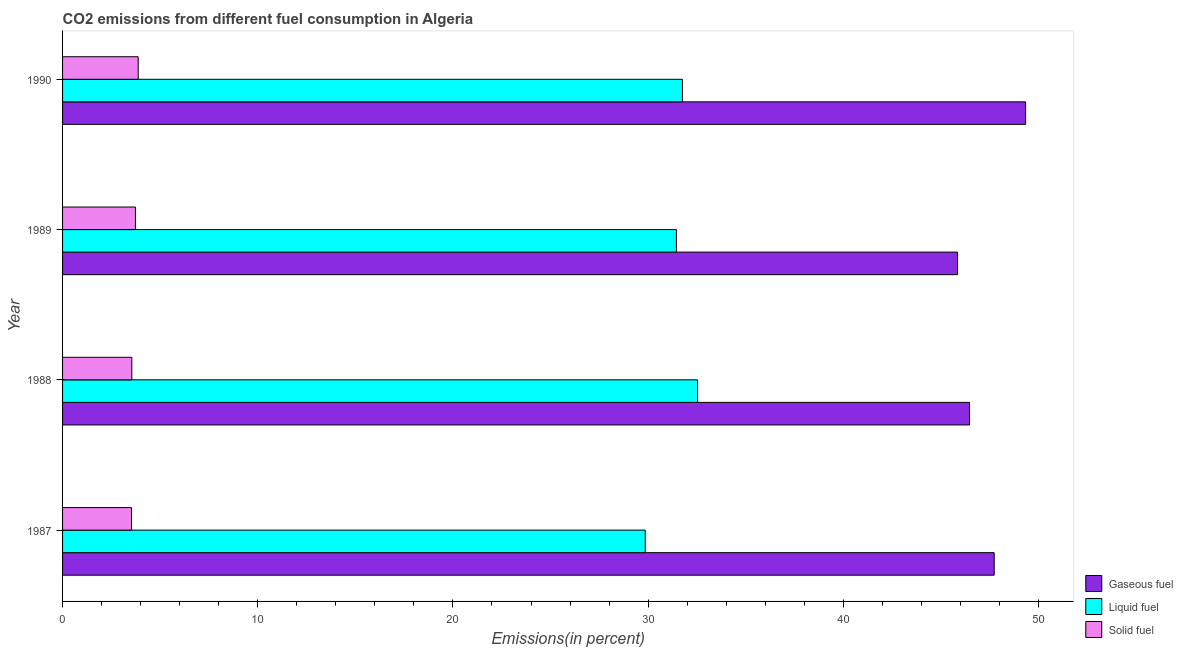How many different coloured bars are there?
Provide a short and direct response. 3. How many groups of bars are there?
Provide a succinct answer. 4. Are the number of bars per tick equal to the number of legend labels?
Make the answer very short. Yes. Are the number of bars on each tick of the Y-axis equal?
Ensure brevity in your answer.  Yes. How many bars are there on the 1st tick from the bottom?
Your response must be concise. 3. What is the percentage of gaseous fuel emission in 1988?
Your response must be concise. 46.46. Across all years, what is the maximum percentage of liquid fuel emission?
Keep it short and to the point. 32.53. Across all years, what is the minimum percentage of solid fuel emission?
Offer a very short reply. 3.53. In which year was the percentage of liquid fuel emission maximum?
Provide a short and direct response. 1988. In which year was the percentage of solid fuel emission minimum?
Keep it short and to the point. 1987. What is the total percentage of gaseous fuel emission in the graph?
Provide a succinct answer. 189.38. What is the difference between the percentage of gaseous fuel emission in 1987 and that in 1988?
Your answer should be compact. 1.26. What is the difference between the percentage of solid fuel emission in 1990 and the percentage of liquid fuel emission in 1988?
Your response must be concise. -28.65. What is the average percentage of liquid fuel emission per year?
Make the answer very short. 31.4. In the year 1990, what is the difference between the percentage of solid fuel emission and percentage of gaseous fuel emission?
Offer a very short reply. -45.46. In how many years, is the percentage of solid fuel emission greater than 26 %?
Make the answer very short. 0. What is the ratio of the percentage of liquid fuel emission in 1987 to that in 1988?
Provide a succinct answer. 0.92. Is the percentage of gaseous fuel emission in 1987 less than that in 1989?
Make the answer very short. No. What is the difference between the highest and the second highest percentage of liquid fuel emission?
Your answer should be very brief. 0.77. What is the difference between the highest and the lowest percentage of solid fuel emission?
Offer a very short reply. 0.34. In how many years, is the percentage of liquid fuel emission greater than the average percentage of liquid fuel emission taken over all years?
Give a very brief answer. 3. Is the sum of the percentage of solid fuel emission in 1988 and 1990 greater than the maximum percentage of gaseous fuel emission across all years?
Provide a short and direct response. No. What does the 2nd bar from the top in 1989 represents?
Make the answer very short. Liquid fuel. What does the 2nd bar from the bottom in 1988 represents?
Your answer should be compact. Liquid fuel. Is it the case that in every year, the sum of the percentage of gaseous fuel emission and percentage of liquid fuel emission is greater than the percentage of solid fuel emission?
Keep it short and to the point. Yes. Are all the bars in the graph horizontal?
Make the answer very short. Yes. Does the graph contain any zero values?
Your answer should be compact. No. How many legend labels are there?
Offer a very short reply. 3. How are the legend labels stacked?
Your answer should be very brief. Vertical. What is the title of the graph?
Provide a succinct answer. CO2 emissions from different fuel consumption in Algeria. Does "Ages 65 and above" appear as one of the legend labels in the graph?
Provide a short and direct response. No. What is the label or title of the X-axis?
Your response must be concise. Emissions(in percent). What is the label or title of the Y-axis?
Make the answer very short. Year. What is the Emissions(in percent) of Gaseous fuel in 1987?
Give a very brief answer. 47.73. What is the Emissions(in percent) of Liquid fuel in 1987?
Keep it short and to the point. 29.85. What is the Emissions(in percent) of Solid fuel in 1987?
Make the answer very short. 3.53. What is the Emissions(in percent) of Gaseous fuel in 1988?
Keep it short and to the point. 46.46. What is the Emissions(in percent) of Liquid fuel in 1988?
Your answer should be compact. 32.53. What is the Emissions(in percent) in Solid fuel in 1988?
Your response must be concise. 3.55. What is the Emissions(in percent) in Gaseous fuel in 1989?
Provide a short and direct response. 45.85. What is the Emissions(in percent) in Liquid fuel in 1989?
Ensure brevity in your answer.  31.45. What is the Emissions(in percent) in Solid fuel in 1989?
Your answer should be compact. 3.73. What is the Emissions(in percent) in Gaseous fuel in 1990?
Your answer should be very brief. 49.34. What is the Emissions(in percent) of Liquid fuel in 1990?
Offer a very short reply. 31.76. What is the Emissions(in percent) of Solid fuel in 1990?
Keep it short and to the point. 3.87. Across all years, what is the maximum Emissions(in percent) in Gaseous fuel?
Provide a succinct answer. 49.34. Across all years, what is the maximum Emissions(in percent) in Liquid fuel?
Offer a very short reply. 32.53. Across all years, what is the maximum Emissions(in percent) in Solid fuel?
Make the answer very short. 3.87. Across all years, what is the minimum Emissions(in percent) of Gaseous fuel?
Your answer should be very brief. 45.85. Across all years, what is the minimum Emissions(in percent) of Liquid fuel?
Provide a short and direct response. 29.85. Across all years, what is the minimum Emissions(in percent) of Solid fuel?
Make the answer very short. 3.53. What is the total Emissions(in percent) in Gaseous fuel in the graph?
Offer a very short reply. 189.38. What is the total Emissions(in percent) in Liquid fuel in the graph?
Give a very brief answer. 125.59. What is the total Emissions(in percent) in Solid fuel in the graph?
Keep it short and to the point. 14.69. What is the difference between the Emissions(in percent) in Gaseous fuel in 1987 and that in 1988?
Your response must be concise. 1.26. What is the difference between the Emissions(in percent) of Liquid fuel in 1987 and that in 1988?
Your answer should be very brief. -2.68. What is the difference between the Emissions(in percent) in Solid fuel in 1987 and that in 1988?
Give a very brief answer. -0.02. What is the difference between the Emissions(in percent) of Gaseous fuel in 1987 and that in 1989?
Your answer should be very brief. 1.88. What is the difference between the Emissions(in percent) of Liquid fuel in 1987 and that in 1989?
Provide a short and direct response. -1.6. What is the difference between the Emissions(in percent) of Solid fuel in 1987 and that in 1989?
Offer a terse response. -0.2. What is the difference between the Emissions(in percent) of Gaseous fuel in 1987 and that in 1990?
Offer a terse response. -1.61. What is the difference between the Emissions(in percent) of Liquid fuel in 1987 and that in 1990?
Your answer should be compact. -1.9. What is the difference between the Emissions(in percent) of Solid fuel in 1987 and that in 1990?
Your answer should be very brief. -0.34. What is the difference between the Emissions(in percent) in Gaseous fuel in 1988 and that in 1989?
Keep it short and to the point. 0.61. What is the difference between the Emissions(in percent) in Liquid fuel in 1988 and that in 1989?
Give a very brief answer. 1.08. What is the difference between the Emissions(in percent) in Solid fuel in 1988 and that in 1989?
Provide a succinct answer. -0.19. What is the difference between the Emissions(in percent) in Gaseous fuel in 1988 and that in 1990?
Give a very brief answer. -2.87. What is the difference between the Emissions(in percent) of Liquid fuel in 1988 and that in 1990?
Make the answer very short. 0.77. What is the difference between the Emissions(in percent) of Solid fuel in 1988 and that in 1990?
Ensure brevity in your answer.  -0.33. What is the difference between the Emissions(in percent) in Gaseous fuel in 1989 and that in 1990?
Make the answer very short. -3.49. What is the difference between the Emissions(in percent) of Liquid fuel in 1989 and that in 1990?
Offer a very short reply. -0.31. What is the difference between the Emissions(in percent) in Solid fuel in 1989 and that in 1990?
Offer a terse response. -0.14. What is the difference between the Emissions(in percent) in Gaseous fuel in 1987 and the Emissions(in percent) in Liquid fuel in 1988?
Offer a very short reply. 15.2. What is the difference between the Emissions(in percent) of Gaseous fuel in 1987 and the Emissions(in percent) of Solid fuel in 1988?
Provide a succinct answer. 44.18. What is the difference between the Emissions(in percent) in Liquid fuel in 1987 and the Emissions(in percent) in Solid fuel in 1988?
Provide a short and direct response. 26.3. What is the difference between the Emissions(in percent) of Gaseous fuel in 1987 and the Emissions(in percent) of Liquid fuel in 1989?
Ensure brevity in your answer.  16.28. What is the difference between the Emissions(in percent) in Gaseous fuel in 1987 and the Emissions(in percent) in Solid fuel in 1989?
Ensure brevity in your answer.  44. What is the difference between the Emissions(in percent) in Liquid fuel in 1987 and the Emissions(in percent) in Solid fuel in 1989?
Provide a succinct answer. 26.12. What is the difference between the Emissions(in percent) of Gaseous fuel in 1987 and the Emissions(in percent) of Liquid fuel in 1990?
Your answer should be compact. 15.97. What is the difference between the Emissions(in percent) of Gaseous fuel in 1987 and the Emissions(in percent) of Solid fuel in 1990?
Keep it short and to the point. 43.85. What is the difference between the Emissions(in percent) in Liquid fuel in 1987 and the Emissions(in percent) in Solid fuel in 1990?
Ensure brevity in your answer.  25.98. What is the difference between the Emissions(in percent) of Gaseous fuel in 1988 and the Emissions(in percent) of Liquid fuel in 1989?
Ensure brevity in your answer.  15.02. What is the difference between the Emissions(in percent) in Gaseous fuel in 1988 and the Emissions(in percent) in Solid fuel in 1989?
Your answer should be very brief. 42.73. What is the difference between the Emissions(in percent) of Liquid fuel in 1988 and the Emissions(in percent) of Solid fuel in 1989?
Offer a terse response. 28.8. What is the difference between the Emissions(in percent) of Gaseous fuel in 1988 and the Emissions(in percent) of Liquid fuel in 1990?
Provide a short and direct response. 14.71. What is the difference between the Emissions(in percent) in Gaseous fuel in 1988 and the Emissions(in percent) in Solid fuel in 1990?
Your answer should be very brief. 42.59. What is the difference between the Emissions(in percent) in Liquid fuel in 1988 and the Emissions(in percent) in Solid fuel in 1990?
Your response must be concise. 28.65. What is the difference between the Emissions(in percent) in Gaseous fuel in 1989 and the Emissions(in percent) in Liquid fuel in 1990?
Your answer should be compact. 14.1. What is the difference between the Emissions(in percent) in Gaseous fuel in 1989 and the Emissions(in percent) in Solid fuel in 1990?
Your answer should be compact. 41.98. What is the difference between the Emissions(in percent) in Liquid fuel in 1989 and the Emissions(in percent) in Solid fuel in 1990?
Offer a very short reply. 27.57. What is the average Emissions(in percent) of Gaseous fuel per year?
Give a very brief answer. 47.35. What is the average Emissions(in percent) of Liquid fuel per year?
Make the answer very short. 31.4. What is the average Emissions(in percent) in Solid fuel per year?
Offer a terse response. 3.67. In the year 1987, what is the difference between the Emissions(in percent) in Gaseous fuel and Emissions(in percent) in Liquid fuel?
Your response must be concise. 17.88. In the year 1987, what is the difference between the Emissions(in percent) in Gaseous fuel and Emissions(in percent) in Solid fuel?
Keep it short and to the point. 44.2. In the year 1987, what is the difference between the Emissions(in percent) of Liquid fuel and Emissions(in percent) of Solid fuel?
Your answer should be very brief. 26.32. In the year 1988, what is the difference between the Emissions(in percent) of Gaseous fuel and Emissions(in percent) of Liquid fuel?
Provide a short and direct response. 13.93. In the year 1988, what is the difference between the Emissions(in percent) of Gaseous fuel and Emissions(in percent) of Solid fuel?
Offer a terse response. 42.92. In the year 1988, what is the difference between the Emissions(in percent) of Liquid fuel and Emissions(in percent) of Solid fuel?
Offer a terse response. 28.98. In the year 1989, what is the difference between the Emissions(in percent) in Gaseous fuel and Emissions(in percent) in Liquid fuel?
Give a very brief answer. 14.4. In the year 1989, what is the difference between the Emissions(in percent) in Gaseous fuel and Emissions(in percent) in Solid fuel?
Give a very brief answer. 42.12. In the year 1989, what is the difference between the Emissions(in percent) of Liquid fuel and Emissions(in percent) of Solid fuel?
Offer a very short reply. 27.72. In the year 1990, what is the difference between the Emissions(in percent) in Gaseous fuel and Emissions(in percent) in Liquid fuel?
Keep it short and to the point. 17.58. In the year 1990, what is the difference between the Emissions(in percent) in Gaseous fuel and Emissions(in percent) in Solid fuel?
Offer a terse response. 45.46. In the year 1990, what is the difference between the Emissions(in percent) of Liquid fuel and Emissions(in percent) of Solid fuel?
Your answer should be very brief. 27.88. What is the ratio of the Emissions(in percent) of Gaseous fuel in 1987 to that in 1988?
Provide a succinct answer. 1.03. What is the ratio of the Emissions(in percent) in Liquid fuel in 1987 to that in 1988?
Your response must be concise. 0.92. What is the ratio of the Emissions(in percent) in Gaseous fuel in 1987 to that in 1989?
Your answer should be very brief. 1.04. What is the ratio of the Emissions(in percent) of Liquid fuel in 1987 to that in 1989?
Your answer should be compact. 0.95. What is the ratio of the Emissions(in percent) in Solid fuel in 1987 to that in 1989?
Your answer should be very brief. 0.95. What is the ratio of the Emissions(in percent) of Gaseous fuel in 1987 to that in 1990?
Ensure brevity in your answer.  0.97. What is the ratio of the Emissions(in percent) of Liquid fuel in 1987 to that in 1990?
Give a very brief answer. 0.94. What is the ratio of the Emissions(in percent) in Solid fuel in 1987 to that in 1990?
Offer a very short reply. 0.91. What is the ratio of the Emissions(in percent) in Gaseous fuel in 1988 to that in 1989?
Your response must be concise. 1.01. What is the ratio of the Emissions(in percent) in Liquid fuel in 1988 to that in 1989?
Your answer should be compact. 1.03. What is the ratio of the Emissions(in percent) of Solid fuel in 1988 to that in 1989?
Your response must be concise. 0.95. What is the ratio of the Emissions(in percent) in Gaseous fuel in 1988 to that in 1990?
Offer a very short reply. 0.94. What is the ratio of the Emissions(in percent) in Liquid fuel in 1988 to that in 1990?
Keep it short and to the point. 1.02. What is the ratio of the Emissions(in percent) in Solid fuel in 1988 to that in 1990?
Your answer should be compact. 0.92. What is the ratio of the Emissions(in percent) of Gaseous fuel in 1989 to that in 1990?
Provide a succinct answer. 0.93. What is the ratio of the Emissions(in percent) in Liquid fuel in 1989 to that in 1990?
Offer a terse response. 0.99. What is the ratio of the Emissions(in percent) in Solid fuel in 1989 to that in 1990?
Your answer should be very brief. 0.96. What is the difference between the highest and the second highest Emissions(in percent) of Gaseous fuel?
Offer a terse response. 1.61. What is the difference between the highest and the second highest Emissions(in percent) in Liquid fuel?
Offer a terse response. 0.77. What is the difference between the highest and the second highest Emissions(in percent) in Solid fuel?
Provide a succinct answer. 0.14. What is the difference between the highest and the lowest Emissions(in percent) of Gaseous fuel?
Your answer should be compact. 3.49. What is the difference between the highest and the lowest Emissions(in percent) in Liquid fuel?
Offer a terse response. 2.68. What is the difference between the highest and the lowest Emissions(in percent) of Solid fuel?
Make the answer very short. 0.34. 